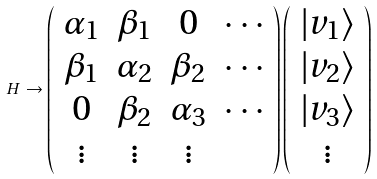<formula> <loc_0><loc_0><loc_500><loc_500>H \rightarrow \left ( \begin{array} { c c c c } \alpha _ { 1 } & \beta _ { 1 } & 0 & \cdots \\ \beta _ { 1 } & \alpha _ { 2 } & \beta _ { 2 } & \cdots \\ 0 & \beta _ { 2 } & \alpha _ { 3 } & \cdots \\ \vdots & \vdots & \vdots & \end{array} \right ) \left ( \begin{array} { c } | v _ { 1 } \rangle \\ | v _ { 2 } \rangle \\ | v _ { 3 } \rangle \\ \vdots \end{array} \right )</formula> 